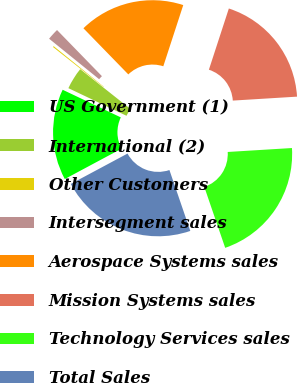Convert chart to OTSL. <chart><loc_0><loc_0><loc_500><loc_500><pie_chart><fcel>US Government (1)<fcel>International (2)<fcel>Other Customers<fcel>Intersegment sales<fcel>Aerospace Systems sales<fcel>Mission Systems sales<fcel>Technology Services sales<fcel>Total Sales<nl><fcel>14.88%<fcel>3.6%<fcel>0.17%<fcel>1.89%<fcel>17.3%<fcel>19.01%<fcel>20.72%<fcel>22.44%<nl></chart> 